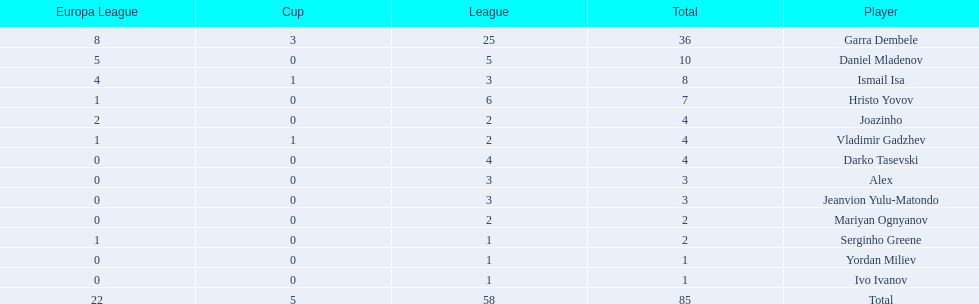What players did not score in all 3 competitions? Daniel Mladenov, Hristo Yovov, Joazinho, Darko Tasevski, Alex, Jeanvion Yulu-Matondo, Mariyan Ognyanov, Serginho Greene, Yordan Miliev, Ivo Ivanov. Which of those did not have total more then 5? Darko Tasevski, Alex, Jeanvion Yulu-Matondo, Mariyan Ognyanov, Serginho Greene, Yordan Miliev, Ivo Ivanov. Which ones scored more then 1 total? Darko Tasevski, Alex, Jeanvion Yulu-Matondo, Mariyan Ognyanov. Which of these player had the lease league points? Mariyan Ognyanov. 